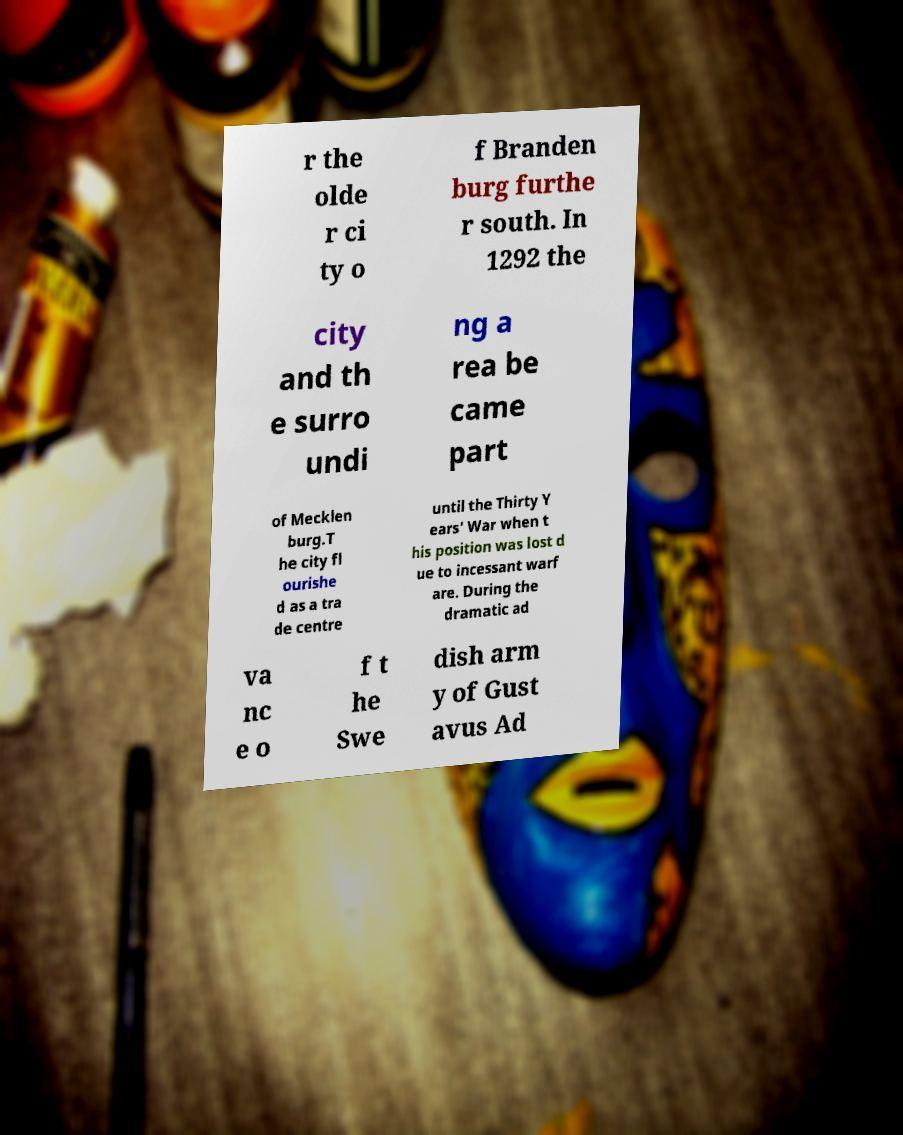What messages or text are displayed in this image? I need them in a readable, typed format. r the olde r ci ty o f Branden burg furthe r south. In 1292 the city and th e surro undi ng a rea be came part of Mecklen burg.T he city fl ourishe d as a tra de centre until the Thirty Y ears' War when t his position was lost d ue to incessant warf are. During the dramatic ad va nc e o f t he Swe dish arm y of Gust avus Ad 